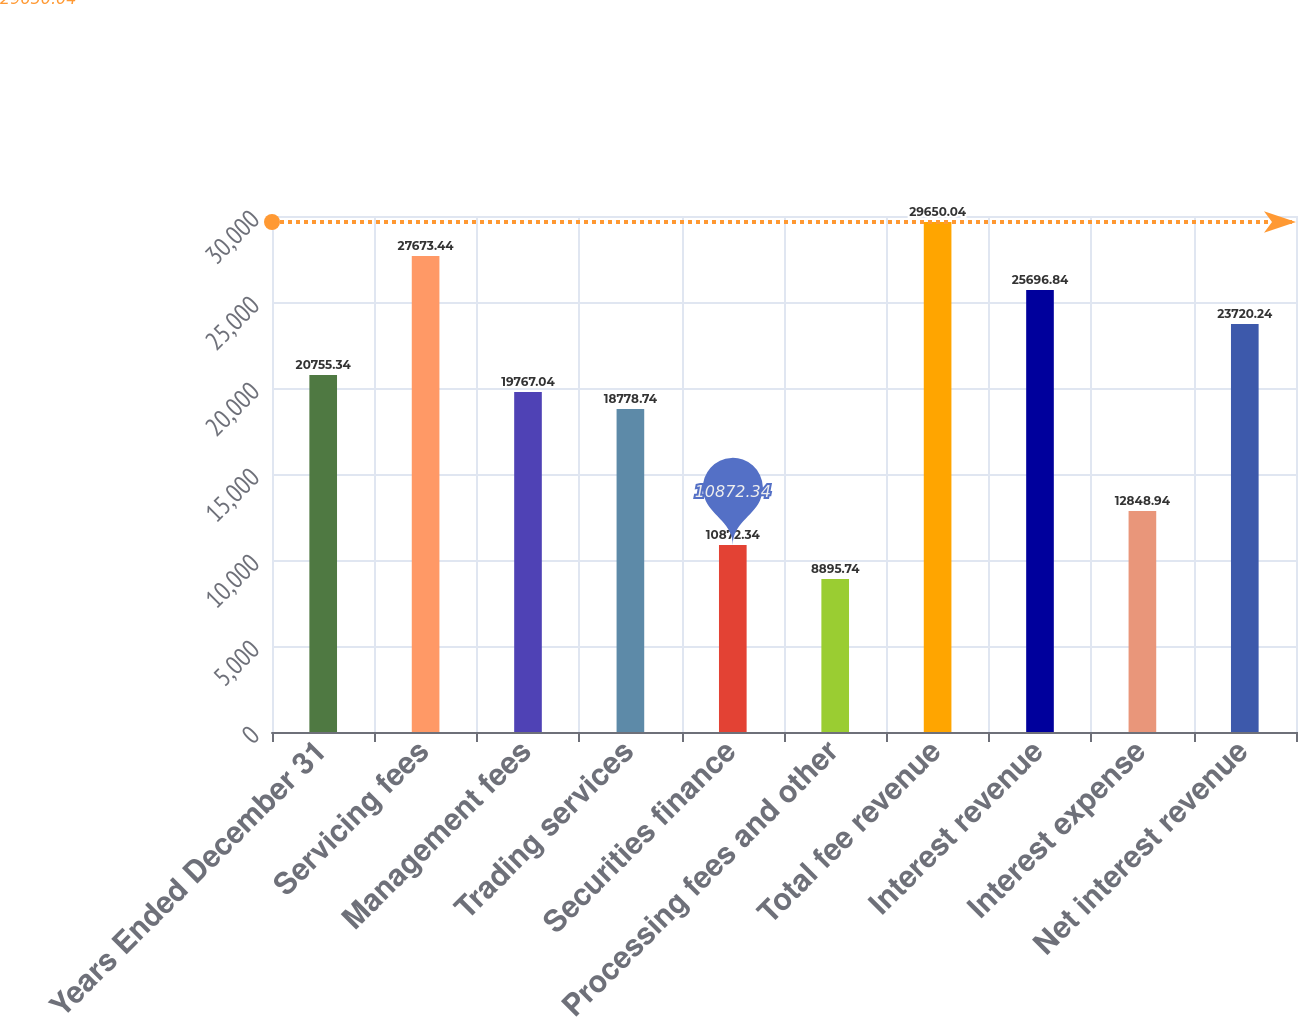Convert chart. <chart><loc_0><loc_0><loc_500><loc_500><bar_chart><fcel>Years Ended December 31<fcel>Servicing fees<fcel>Management fees<fcel>Trading services<fcel>Securities finance<fcel>Processing fees and other<fcel>Total fee revenue<fcel>Interest revenue<fcel>Interest expense<fcel>Net interest revenue<nl><fcel>20755.3<fcel>27673.4<fcel>19767<fcel>18778.7<fcel>10872.3<fcel>8895.74<fcel>29650<fcel>25696.8<fcel>12848.9<fcel>23720.2<nl></chart> 